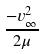Convert formula to latex. <formula><loc_0><loc_0><loc_500><loc_500>\frac { - v _ { \infty } ^ { 2 } } { 2 \mu }</formula> 